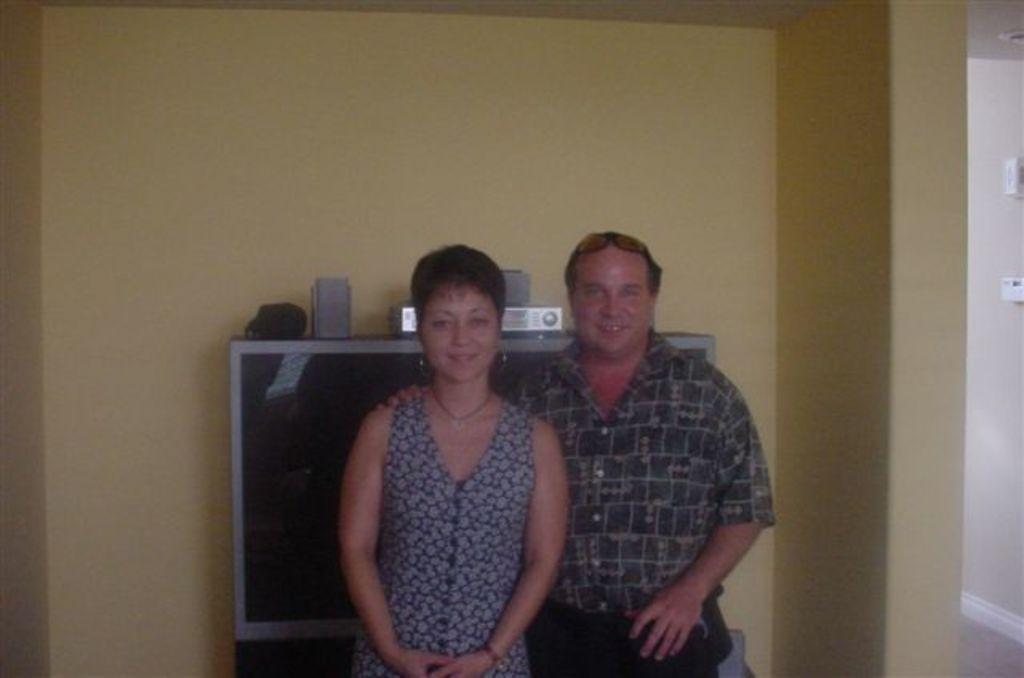Please provide a concise description of this image. In this picture, we can see a few people, and we can see the wall with some objects. 